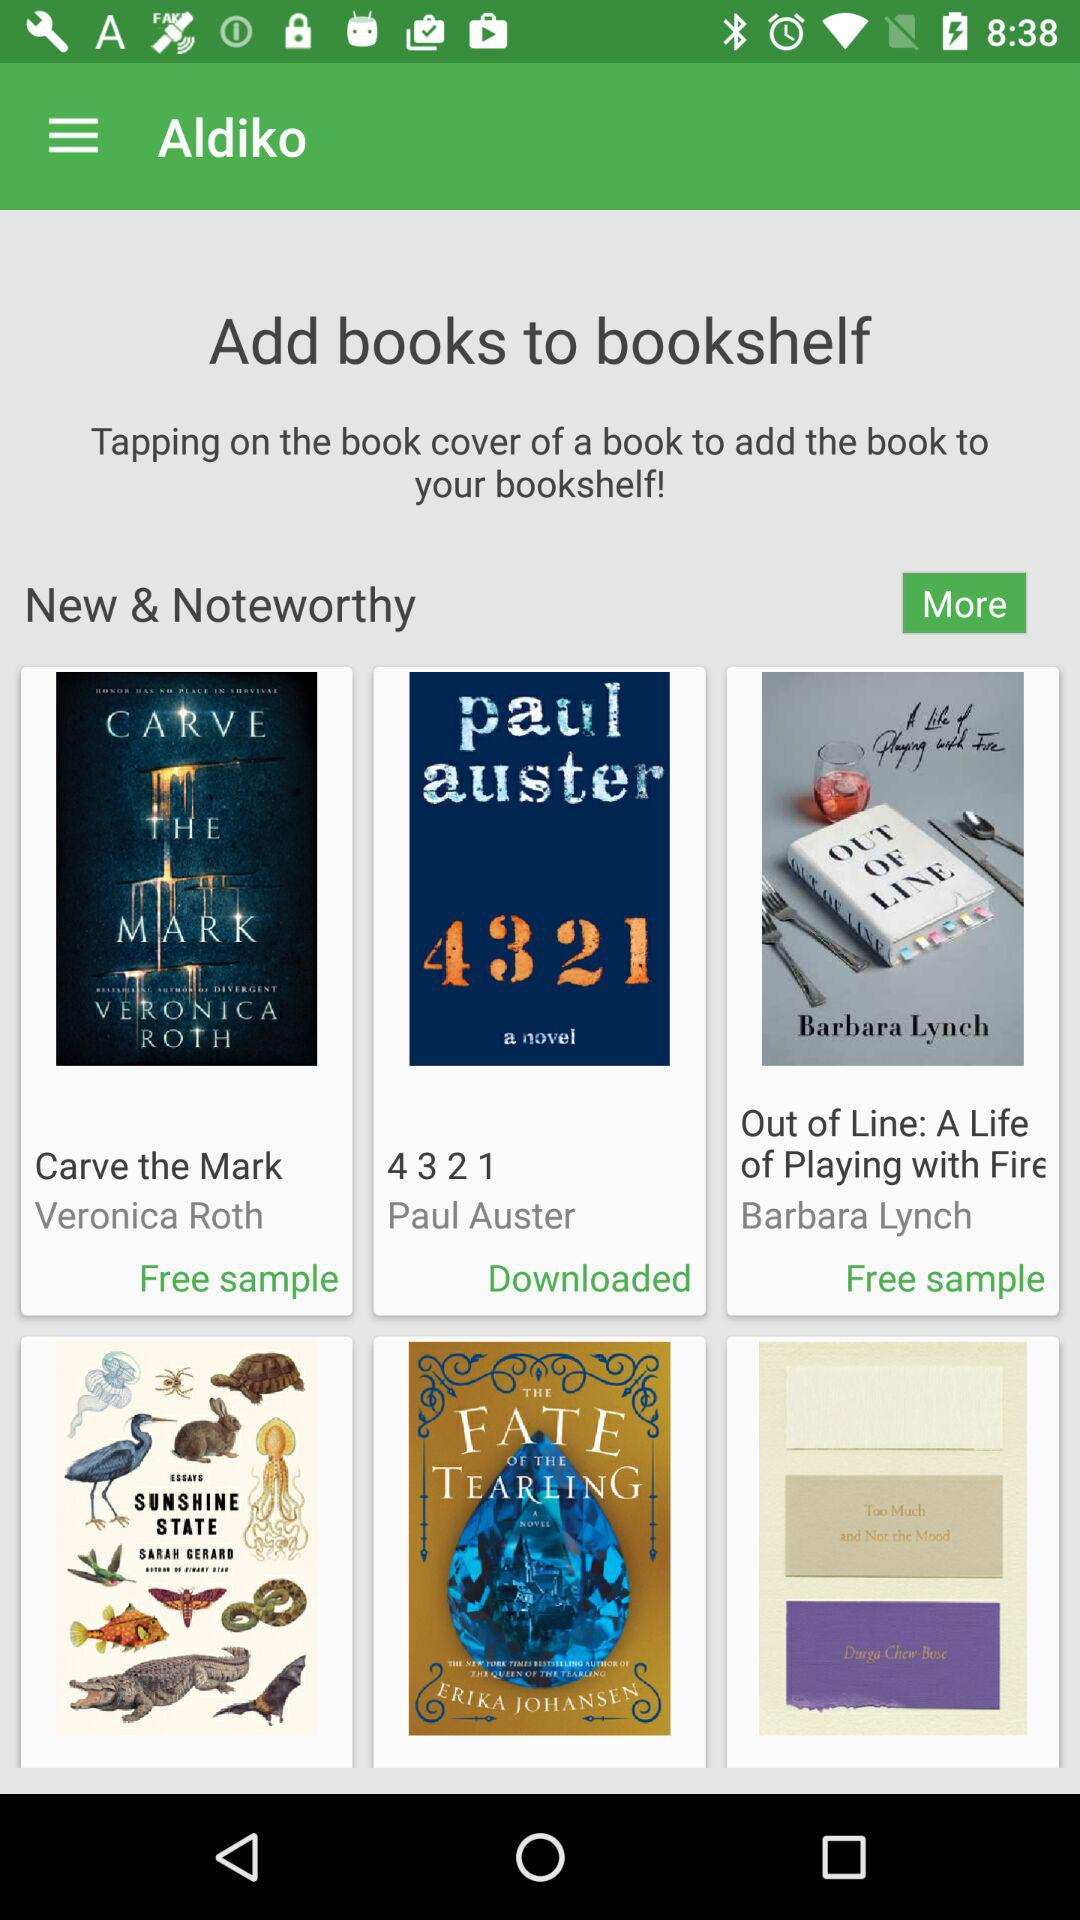Who's the author of the book "Carve the Mark"? The author of the book is "Veronica Roth". 